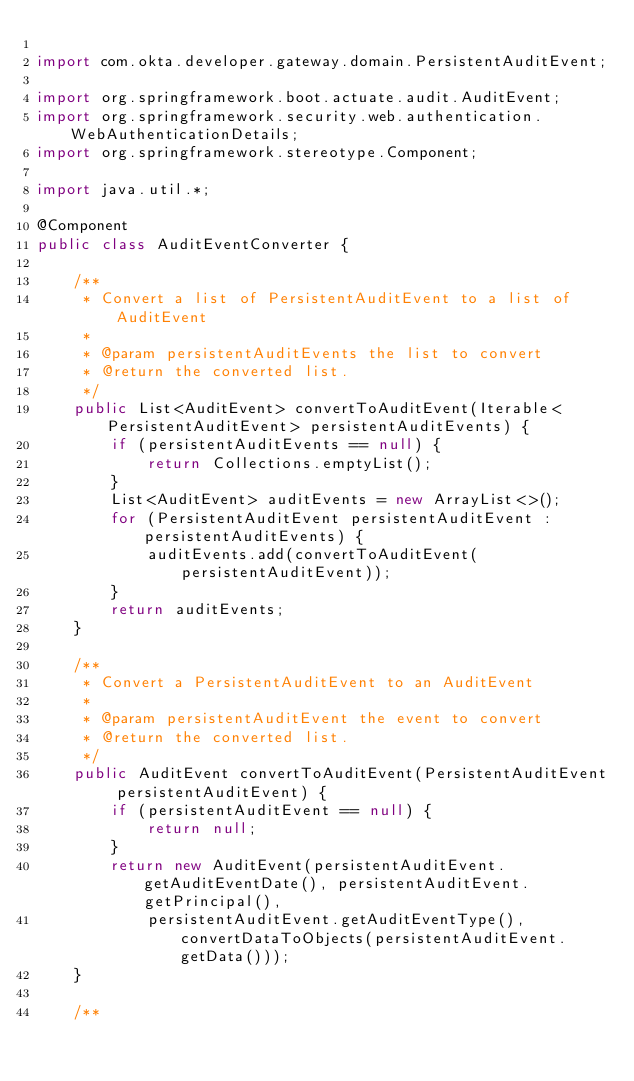<code> <loc_0><loc_0><loc_500><loc_500><_Java_>
import com.okta.developer.gateway.domain.PersistentAuditEvent;

import org.springframework.boot.actuate.audit.AuditEvent;
import org.springframework.security.web.authentication.WebAuthenticationDetails;
import org.springframework.stereotype.Component;

import java.util.*;

@Component
public class AuditEventConverter {

    /**
     * Convert a list of PersistentAuditEvent to a list of AuditEvent
     *
     * @param persistentAuditEvents the list to convert
     * @return the converted list.
     */
    public List<AuditEvent> convertToAuditEvent(Iterable<PersistentAuditEvent> persistentAuditEvents) {
        if (persistentAuditEvents == null) {
            return Collections.emptyList();
        }
        List<AuditEvent> auditEvents = new ArrayList<>();
        for (PersistentAuditEvent persistentAuditEvent : persistentAuditEvents) {
            auditEvents.add(convertToAuditEvent(persistentAuditEvent));
        }
        return auditEvents;
    }

    /**
     * Convert a PersistentAuditEvent to an AuditEvent
     *
     * @param persistentAuditEvent the event to convert
     * @return the converted list.
     */
    public AuditEvent convertToAuditEvent(PersistentAuditEvent persistentAuditEvent) {
        if (persistentAuditEvent == null) {
            return null;
        }
        return new AuditEvent(persistentAuditEvent.getAuditEventDate(), persistentAuditEvent.getPrincipal(),
            persistentAuditEvent.getAuditEventType(), convertDataToObjects(persistentAuditEvent.getData()));
    }

    /**</code> 